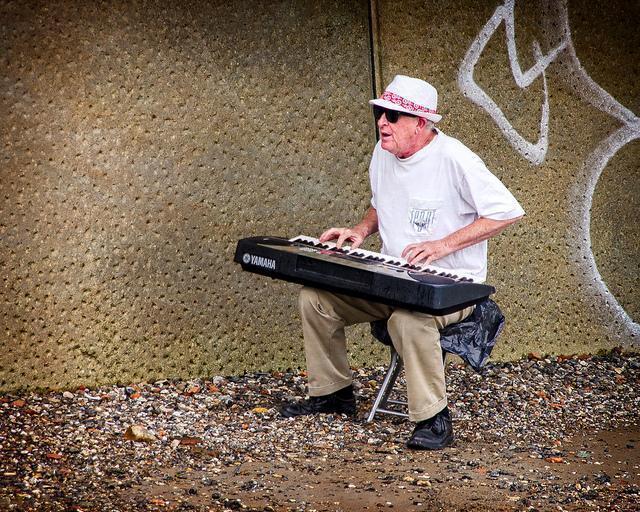What powers the musical instrument shown here?
Make your selection from the four choices given to correctly answer the question.
Options: Solar, gas, battery, oil. Battery. 